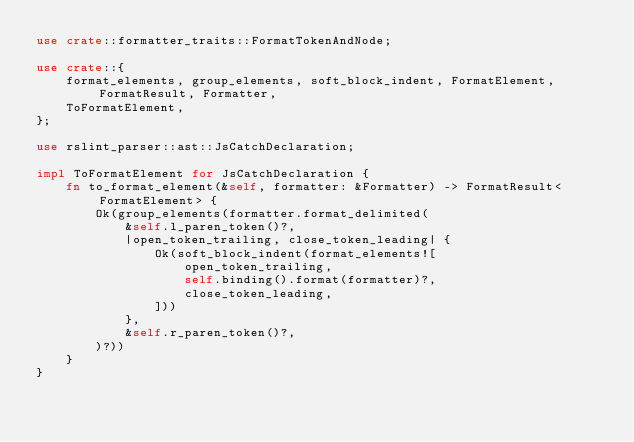<code> <loc_0><loc_0><loc_500><loc_500><_Rust_>use crate::formatter_traits::FormatTokenAndNode;

use crate::{
    format_elements, group_elements, soft_block_indent, FormatElement, FormatResult, Formatter,
    ToFormatElement,
};

use rslint_parser::ast::JsCatchDeclaration;

impl ToFormatElement for JsCatchDeclaration {
    fn to_format_element(&self, formatter: &Formatter) -> FormatResult<FormatElement> {
        Ok(group_elements(formatter.format_delimited(
            &self.l_paren_token()?,
            |open_token_trailing, close_token_leading| {
                Ok(soft_block_indent(format_elements![
                    open_token_trailing,
                    self.binding().format(formatter)?,
                    close_token_leading,
                ]))
            },
            &self.r_paren_token()?,
        )?))
    }
}
</code> 